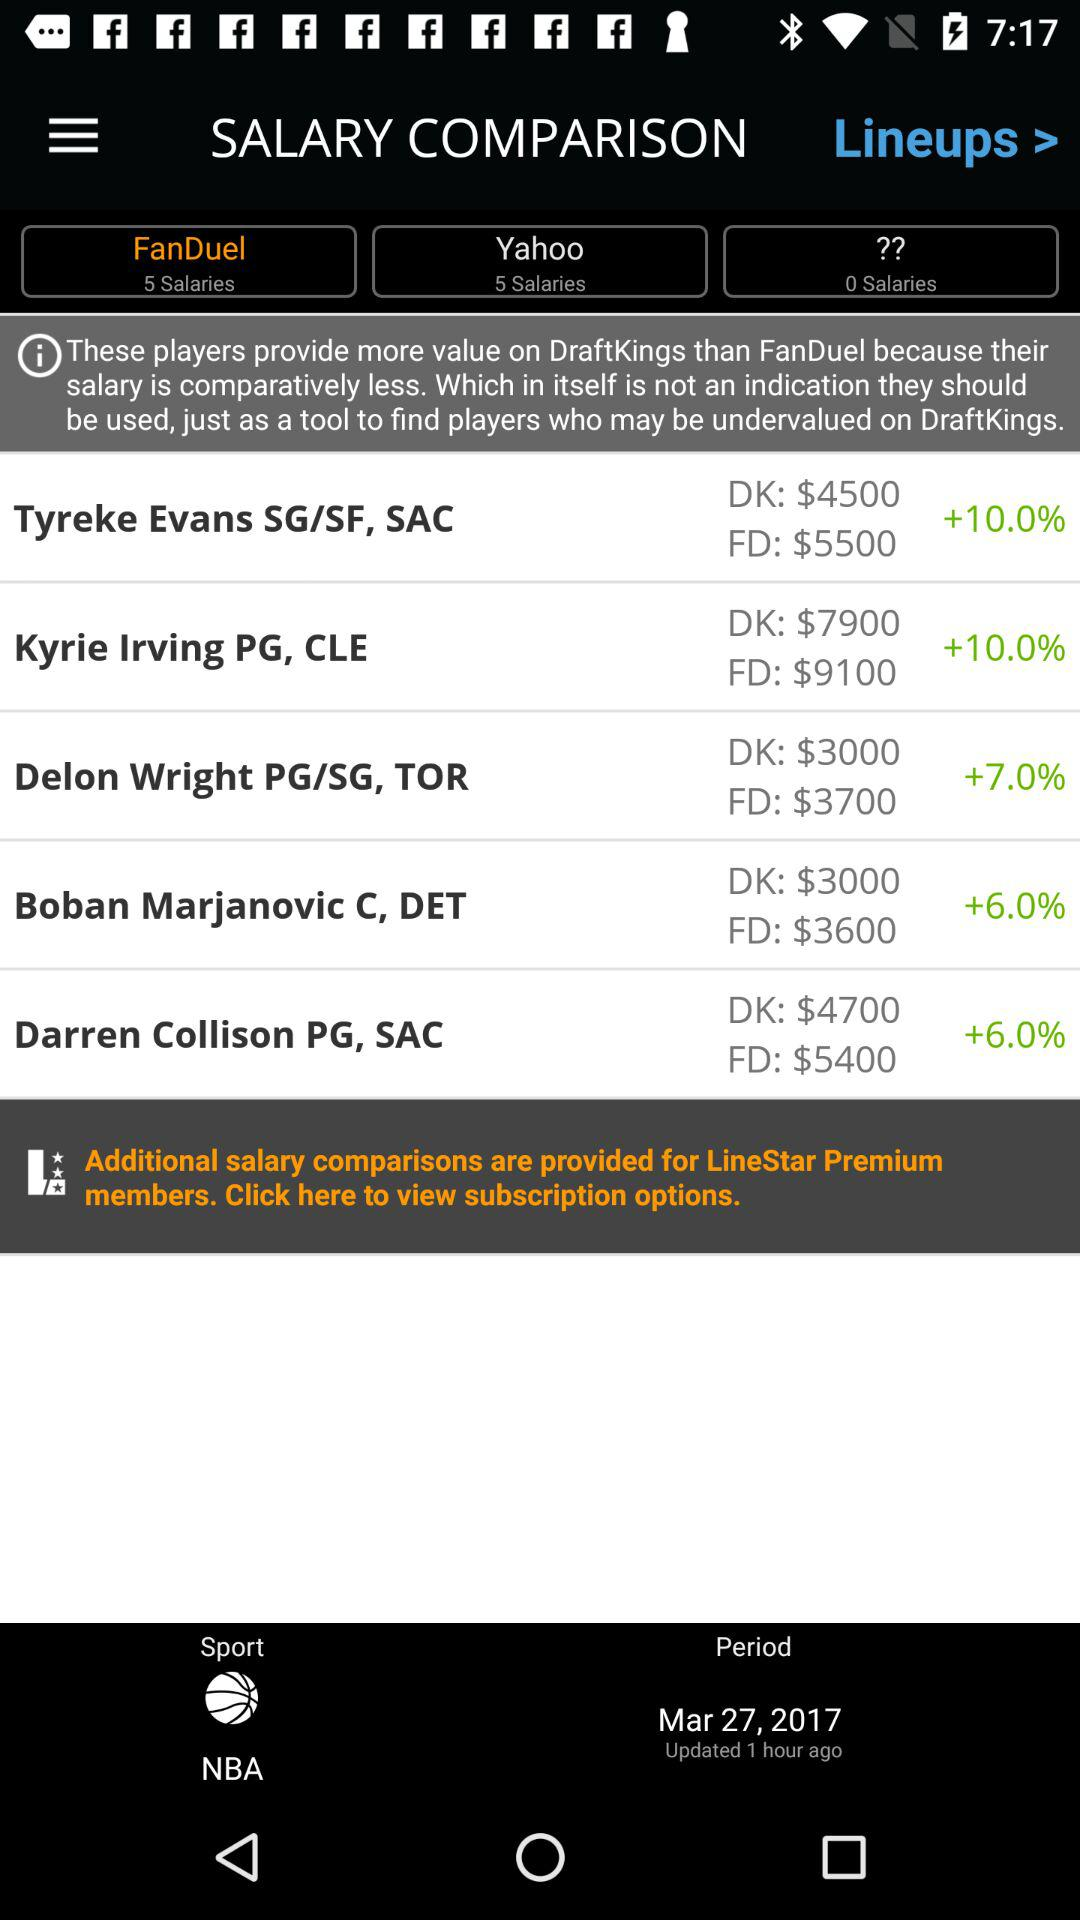How many salaries are there on Yahoo? There are 5 salaries on Yahoo. 